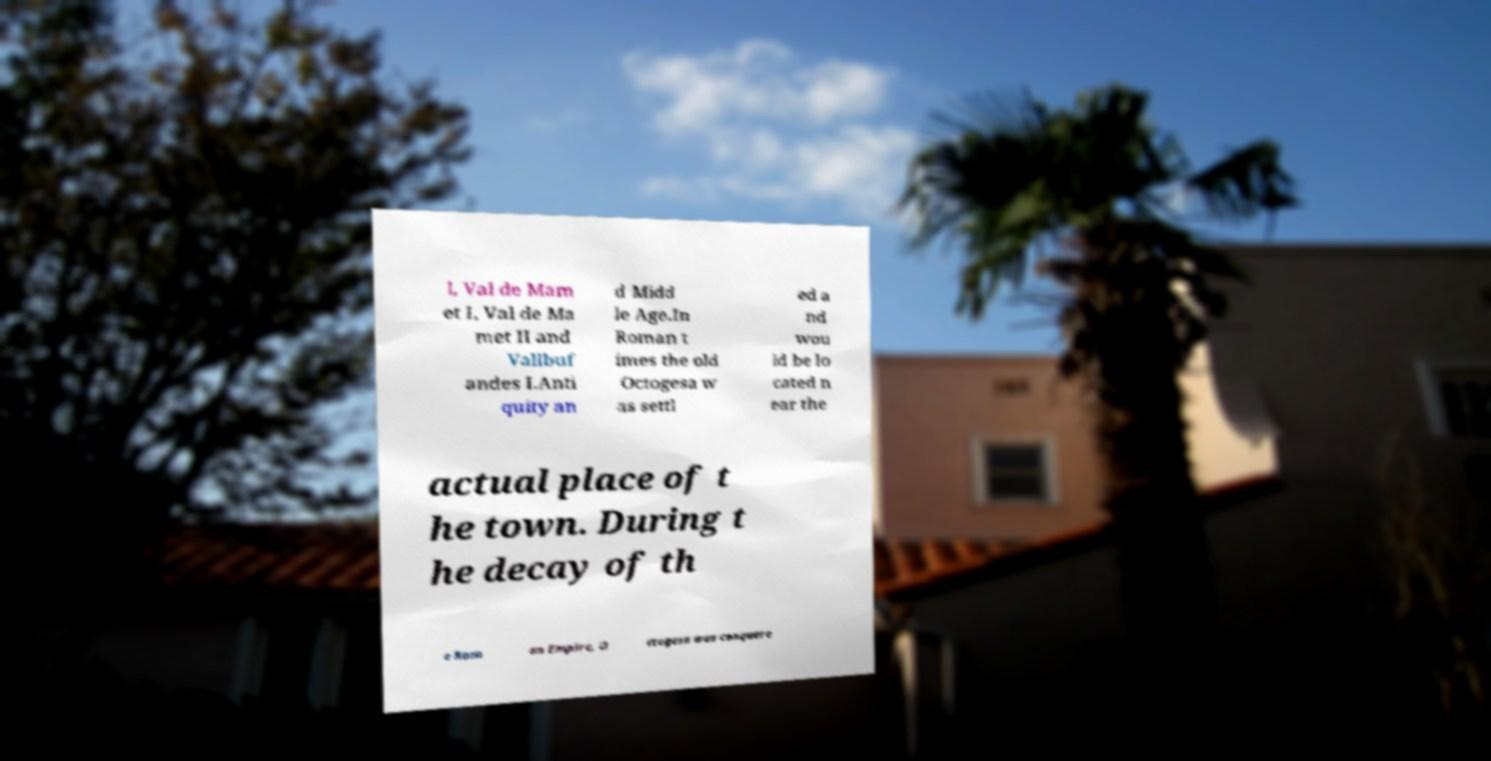Please identify and transcribe the text found in this image. l, Val de Mam et I, Val de Ma met II and Vallbuf andes I.Anti quity an d Midd le Age.In Roman t imes the old Octogesa w as settl ed a nd wou ld be lo cated n ear the actual place of t he town. During t he decay of th e Rom an Empire, O ctogesa was conquere 